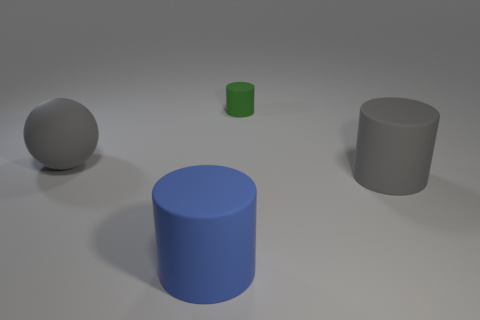There is a matte ball; is it the same color as the big cylinder right of the green rubber thing?
Provide a short and direct response. Yes. Are there any brown rubber cylinders of the same size as the blue rubber cylinder?
Offer a terse response. No. How many large matte cylinders are the same color as the large ball?
Your answer should be compact. 1. There is a large blue thing that is the same material as the tiny cylinder; what shape is it?
Provide a short and direct response. Cylinder. There is a matte cylinder that is behind the gray cylinder; what is its size?
Your answer should be very brief. Small. Are there an equal number of tiny green rubber things that are in front of the gray cylinder and large cylinders in front of the blue matte thing?
Make the answer very short. Yes. There is a large cylinder in front of the large gray rubber object on the right side of the rubber thing behind the large sphere; what is its color?
Make the answer very short. Blue. What number of big cylinders are on the left side of the tiny cylinder and to the right of the tiny green cylinder?
Your answer should be compact. 0. There is a big rubber thing to the right of the blue matte cylinder; is its color the same as the big rubber ball in front of the small green rubber cylinder?
Provide a succinct answer. Yes. What is the size of the gray thing that is the same shape as the green rubber thing?
Offer a very short reply. Large. 